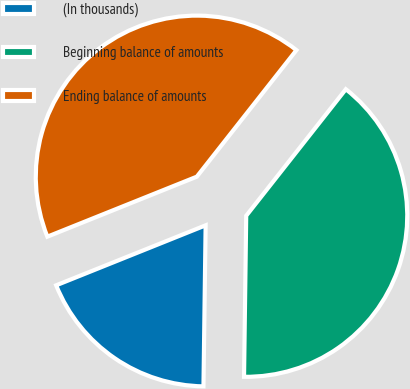<chart> <loc_0><loc_0><loc_500><loc_500><pie_chart><fcel>(In thousands)<fcel>Beginning balance of amounts<fcel>Ending balance of amounts<nl><fcel>18.71%<fcel>39.6%<fcel>41.69%<nl></chart> 